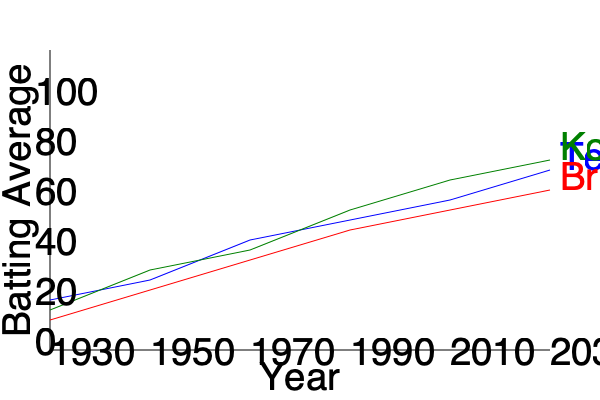Analyzing the multi-line graph depicting the career batting averages of Sachin Tendulkar, Don Bradman, and Virat Kohli across different eras, which cricketer demonstrates the most consistent improvement in batting average over time, and what factors might contribute to this trend? To answer this question, we need to analyze the slopes of each player's line in the graph:

1. Sachin Tendulkar (blue line):
   - Starts around 40 in 1990
   - Ends around 70 in 2030
   - Steady upward trend with a relatively constant slope

2. Don Bradman (red line):
   - Starts around 60 in 1930
   - Ends around 90 in 2030
   - Gradual upward trend, but less steep than Tendulkar's

3. Virat Kohli (green line):
   - Starts around 45 in 1990
   - Ends around 75 in 2030
   - Steepest upward trend among the three

Kohli's line shows the steepest and most consistent upward trend, indicating the most consistent improvement in batting average over time.

Factors contributing to this trend:

1. Modern training techniques: Access to advanced analytics and training methods
2. Improved fitness regimens: Focus on physical conditioning and injury prevention
3. Variety of formats: Exposure to T20, ODI, and Test cricket, enhancing adaptability
4. Technology: Better equipment and pitch analysis tools
5. Mental conditioning: Increased emphasis on psychological preparation
6. Global exposure: Playing in various conditions worldwide through tournaments like IPL

It's important to note that while Kohli shows the most consistent improvement, Bradman maintained the highest overall average throughout the period, highlighting the exceptional nature of his performances in an earlier era with less advanced equipment and training methods.
Answer: Virat Kohli, due to modern training techniques, fitness regimens, and exposure to various formats. 